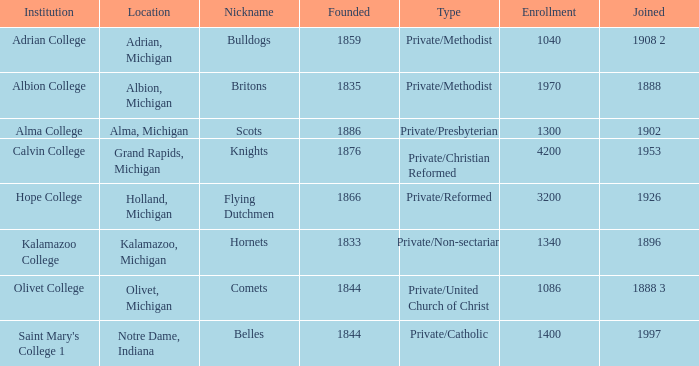In 1953, which of the establishments merged? Calvin College. 